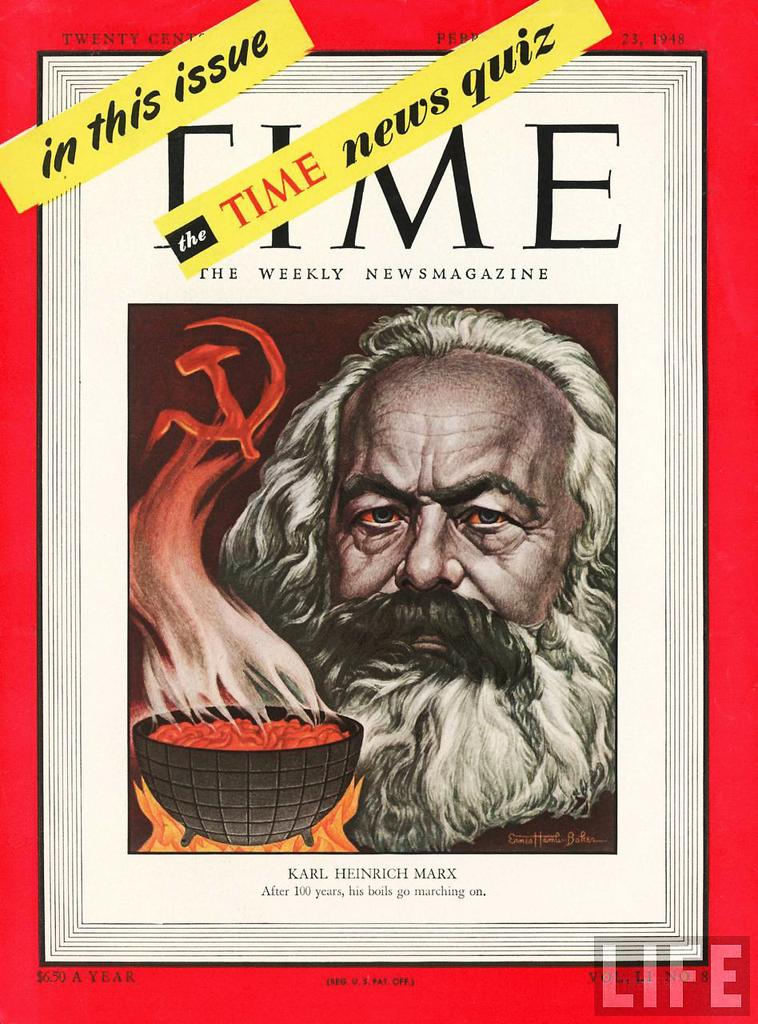<image>
Write a terse but informative summary of the picture. Time the weekly newsmagazine by Karl Heinrich Marx 